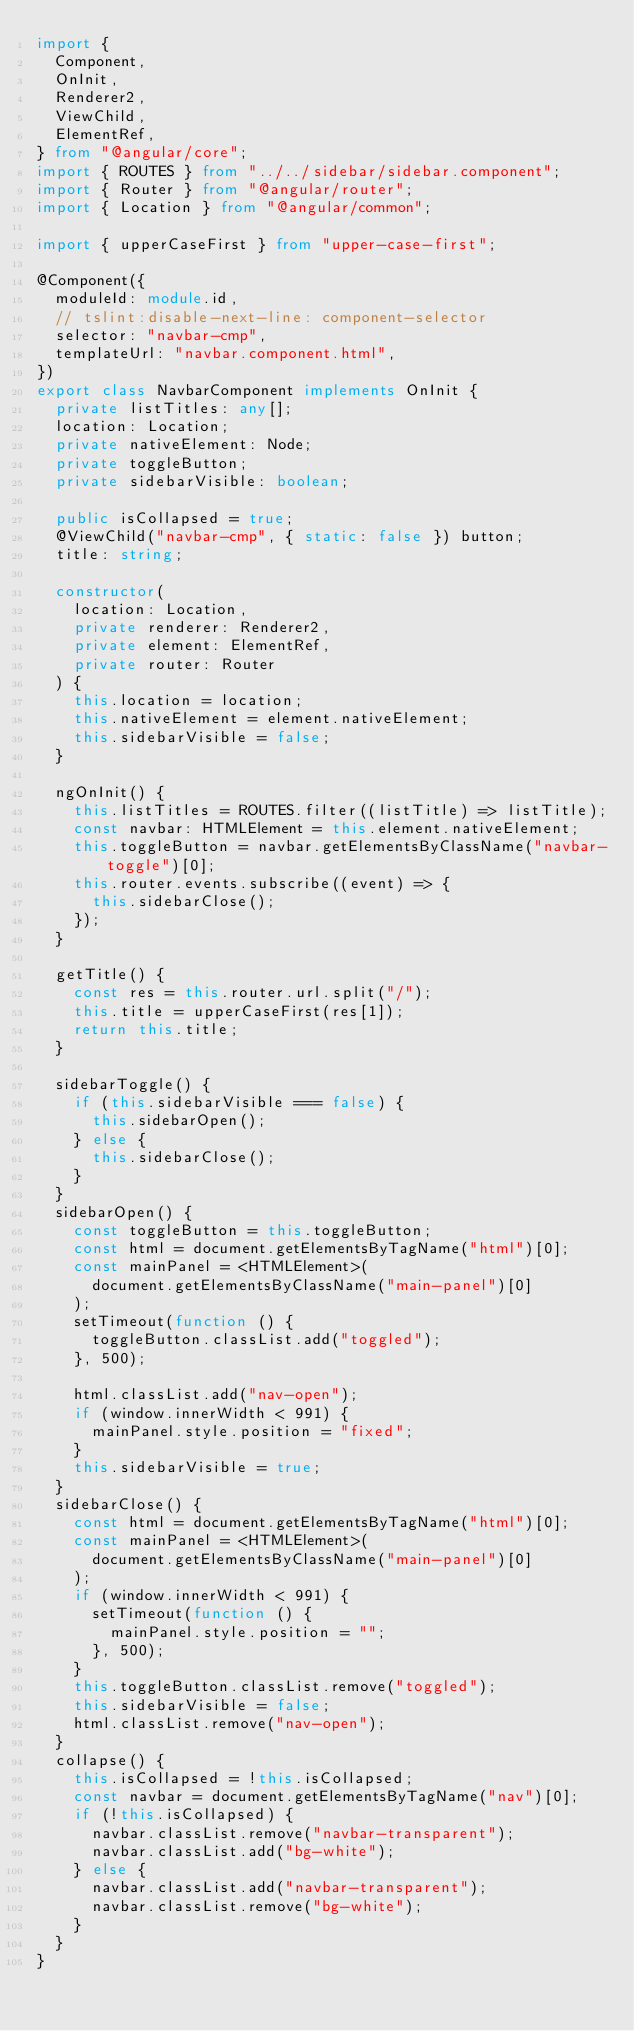<code> <loc_0><loc_0><loc_500><loc_500><_TypeScript_>import {
  Component,
  OnInit,
  Renderer2,
  ViewChild,
  ElementRef,
} from "@angular/core";
import { ROUTES } from "../../sidebar/sidebar.component";
import { Router } from "@angular/router";
import { Location } from "@angular/common";

import { upperCaseFirst } from "upper-case-first";

@Component({
  moduleId: module.id,
  // tslint:disable-next-line: component-selector
  selector: "navbar-cmp",
  templateUrl: "navbar.component.html",
})
export class NavbarComponent implements OnInit {
  private listTitles: any[];
  location: Location;
  private nativeElement: Node;
  private toggleButton;
  private sidebarVisible: boolean;

  public isCollapsed = true;
  @ViewChild("navbar-cmp", { static: false }) button;
  title: string;

  constructor(
    location: Location,
    private renderer: Renderer2,
    private element: ElementRef,
    private router: Router
  ) {
    this.location = location;
    this.nativeElement = element.nativeElement;
    this.sidebarVisible = false;
  }

  ngOnInit() {
    this.listTitles = ROUTES.filter((listTitle) => listTitle);
    const navbar: HTMLElement = this.element.nativeElement;
    this.toggleButton = navbar.getElementsByClassName("navbar-toggle")[0];
    this.router.events.subscribe((event) => {
      this.sidebarClose();
    });
  }

  getTitle() {
    const res = this.router.url.split("/");
    this.title = upperCaseFirst(res[1]);
    return this.title;
  }

  sidebarToggle() {
    if (this.sidebarVisible === false) {
      this.sidebarOpen();
    } else {
      this.sidebarClose();
    }
  }
  sidebarOpen() {
    const toggleButton = this.toggleButton;
    const html = document.getElementsByTagName("html")[0];
    const mainPanel = <HTMLElement>(
      document.getElementsByClassName("main-panel")[0]
    );
    setTimeout(function () {
      toggleButton.classList.add("toggled");
    }, 500);

    html.classList.add("nav-open");
    if (window.innerWidth < 991) {
      mainPanel.style.position = "fixed";
    }
    this.sidebarVisible = true;
  }
  sidebarClose() {
    const html = document.getElementsByTagName("html")[0];
    const mainPanel = <HTMLElement>(
      document.getElementsByClassName("main-panel")[0]
    );
    if (window.innerWidth < 991) {
      setTimeout(function () {
        mainPanel.style.position = "";
      }, 500);
    }
    this.toggleButton.classList.remove("toggled");
    this.sidebarVisible = false;
    html.classList.remove("nav-open");
  }
  collapse() {
    this.isCollapsed = !this.isCollapsed;
    const navbar = document.getElementsByTagName("nav")[0];
    if (!this.isCollapsed) {
      navbar.classList.remove("navbar-transparent");
      navbar.classList.add("bg-white");
    } else {
      navbar.classList.add("navbar-transparent");
      navbar.classList.remove("bg-white");
    }
  }
}
</code> 